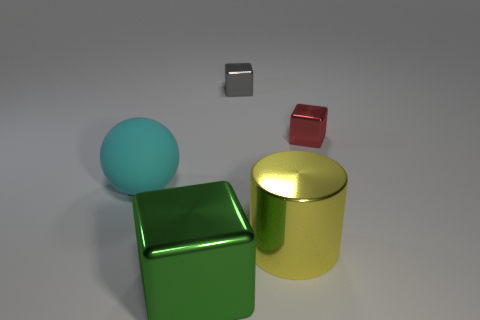How many things are tiny yellow shiny objects or shiny things behind the green block?
Your answer should be very brief. 3. Are there any small gray things that have the same shape as the large green metal thing?
Give a very brief answer. Yes. Are there the same number of small red shiny things that are to the left of the large cyan sphere and large shiny cubes behind the yellow metal cylinder?
Your response must be concise. Yes. What number of gray objects are large rubber spheres or tiny metallic things?
Make the answer very short. 1. What number of red metallic things have the same size as the gray thing?
Offer a terse response. 1. What is the color of the block that is both to the left of the red thing and in front of the gray object?
Give a very brief answer. Green. Are there more green things left of the yellow metal cylinder than large cyan shiny objects?
Provide a short and direct response. Yes. Are any cyan shiny objects visible?
Provide a succinct answer. No. What number of tiny things are either green metallic blocks or matte balls?
Ensure brevity in your answer.  0. Is there anything else that is the same color as the ball?
Offer a terse response. No. 